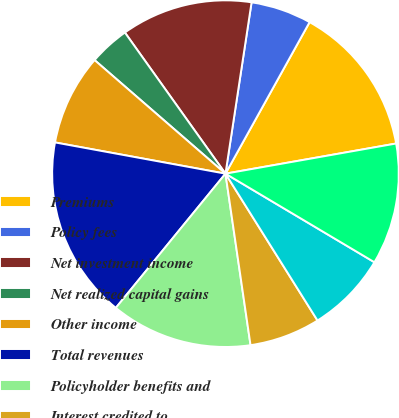Convert chart to OTSL. <chart><loc_0><loc_0><loc_500><loc_500><pie_chart><fcel>Premiums<fcel>Policy fees<fcel>Net investment income<fcel>Net realized capital gains<fcel>Other income<fcel>Total revenues<fcel>Policyholder benefits and<fcel>Interest credited to<fcel>Amortization of deferred<fcel>General operating and other<nl><fcel>14.15%<fcel>5.66%<fcel>12.26%<fcel>3.77%<fcel>8.49%<fcel>16.98%<fcel>13.21%<fcel>6.6%<fcel>7.55%<fcel>11.32%<nl></chart> 